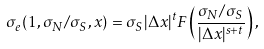<formula> <loc_0><loc_0><loc_500><loc_500>\sigma _ { e } ( 1 , \sigma _ { N } / \sigma _ { S } , x ) = \sigma _ { S } | \Delta x | ^ { t } F \left ( \frac { \sigma _ { N } / \sigma _ { S } } { | \Delta x | ^ { s + t } } \right ) ,</formula> 